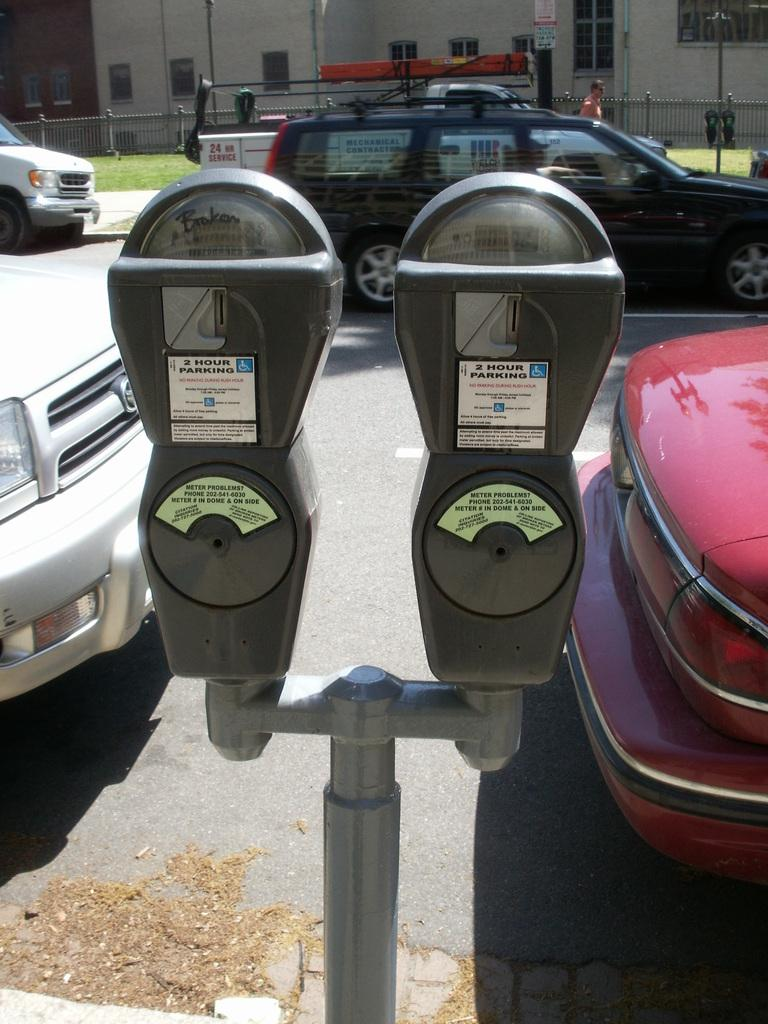Provide a one-sentence caption for the provided image. A pole with two parking meters on it with the left one reading that it is broken. 